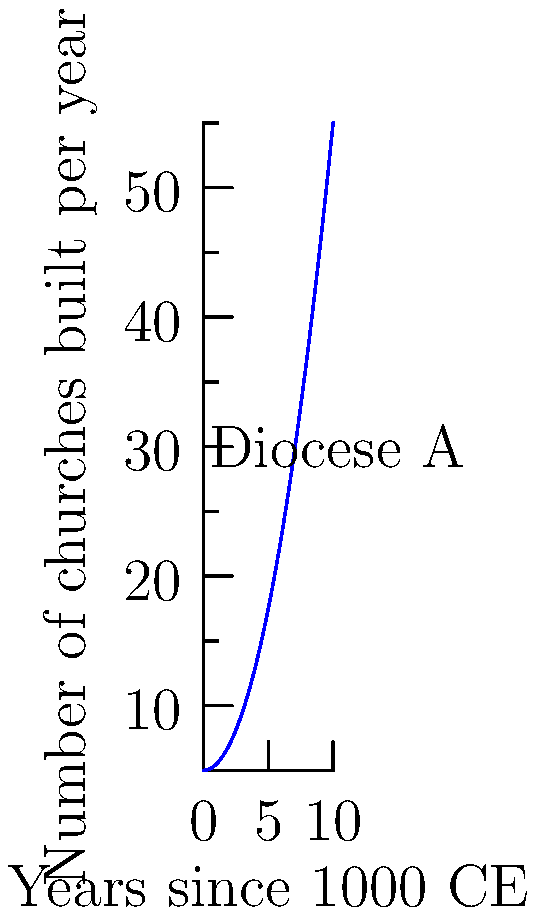The graph shows the rate of church construction in Diocese A from the year 1000 CE. If this trend continues, what will be the instantaneous rate of change in church construction 15 years after 1000 CE? Express your answer in churches per year. To solve this problem, we need to follow these steps:

1) The graph represents a quadratic function. We can see that it has the general form:
   $f(x) = ax^2 + bx + c$

2) From the graph, we can estimate that when $x=0$ (year 1000 CE), $f(0) = 5$. So $c = 5$.

3) The coefficient $a$ determines the steepness of the parabola. We can estimate $a = 0.5$.

4) There doesn't appear to be a linear term, so $b = 0$.

5) Thus, our function is approximately:
   $f(x) = 0.5x^2 + 5$

6) To find the instantaneous rate of change, we need to find the derivative of this function:
   $f'(x) = x$

7) We're asked about the rate 15 years after 1000 CE, so we need to evaluate $f'(15)$:
   $f'(15) = 15$

Therefore, 15 years after 1000 CE, the instantaneous rate of change in church construction would be 15 churches per year.
Answer: 15 churches per year 